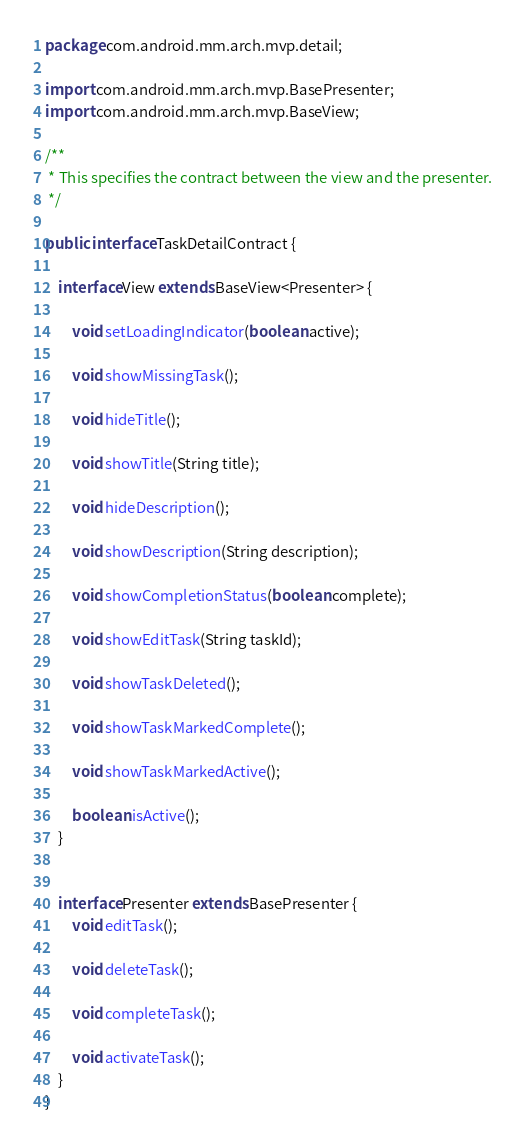<code> <loc_0><loc_0><loc_500><loc_500><_Java_>package com.android.mm.arch.mvp.detail;

import com.android.mm.arch.mvp.BasePresenter;
import com.android.mm.arch.mvp.BaseView;

/**
 * This specifies the contract between the view and the presenter.
 */

public interface TaskDetailContract {

    interface View extends BaseView<Presenter> {

        void setLoadingIndicator(boolean active);

        void showMissingTask();

        void hideTitle();

        void showTitle(String title);

        void hideDescription();

        void showDescription(String description);

        void showCompletionStatus(boolean complete);

        void showEditTask(String taskId);

        void showTaskDeleted();

        void showTaskMarkedComplete();

        void showTaskMarkedActive();

        boolean isActive();
    }


    interface Presenter extends BasePresenter {
        void editTask();

        void deleteTask();

        void completeTask();

        void activateTask();
    }
}
</code> 